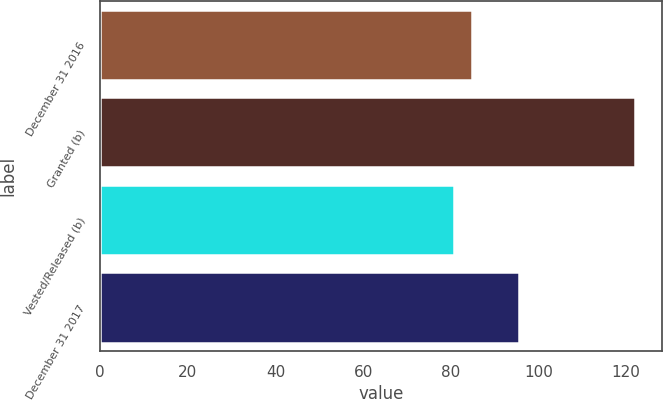Convert chart. <chart><loc_0><loc_0><loc_500><loc_500><bar_chart><fcel>December 31 2016<fcel>Granted (b)<fcel>Vested/Released (b)<fcel>December 31 2017<nl><fcel>84.83<fcel>122.09<fcel>80.69<fcel>95.64<nl></chart> 